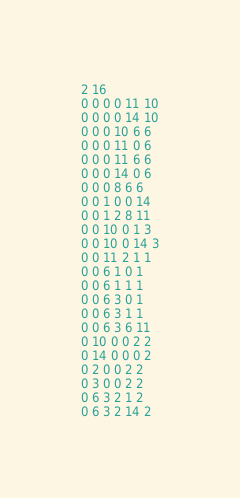Convert code to text. <code><loc_0><loc_0><loc_500><loc_500><_SQL_>2 16
0 0 0 0 11 10
0 0 0 0 14 10
0 0 0 10 6 6
0 0 0 11 0 6
0 0 0 11 6 6
0 0 0 14 0 6
0 0 0 8 6 6
0 0 1 0 0 14
0 0 1 2 8 11
0 0 10 0 1 3
0 0 10 0 14 3
0 0 11 2 1 1
0 0 6 1 0 1
0 0 6 1 1 1
0 0 6 3 0 1
0 0 6 3 1 1
0 0 6 3 6 11
0 10 0 0 2 2
0 14 0 0 0 2
0 2 0 0 2 2
0 3 0 0 2 2
0 6 3 2 1 2
0 6 3 2 14 2</code> 